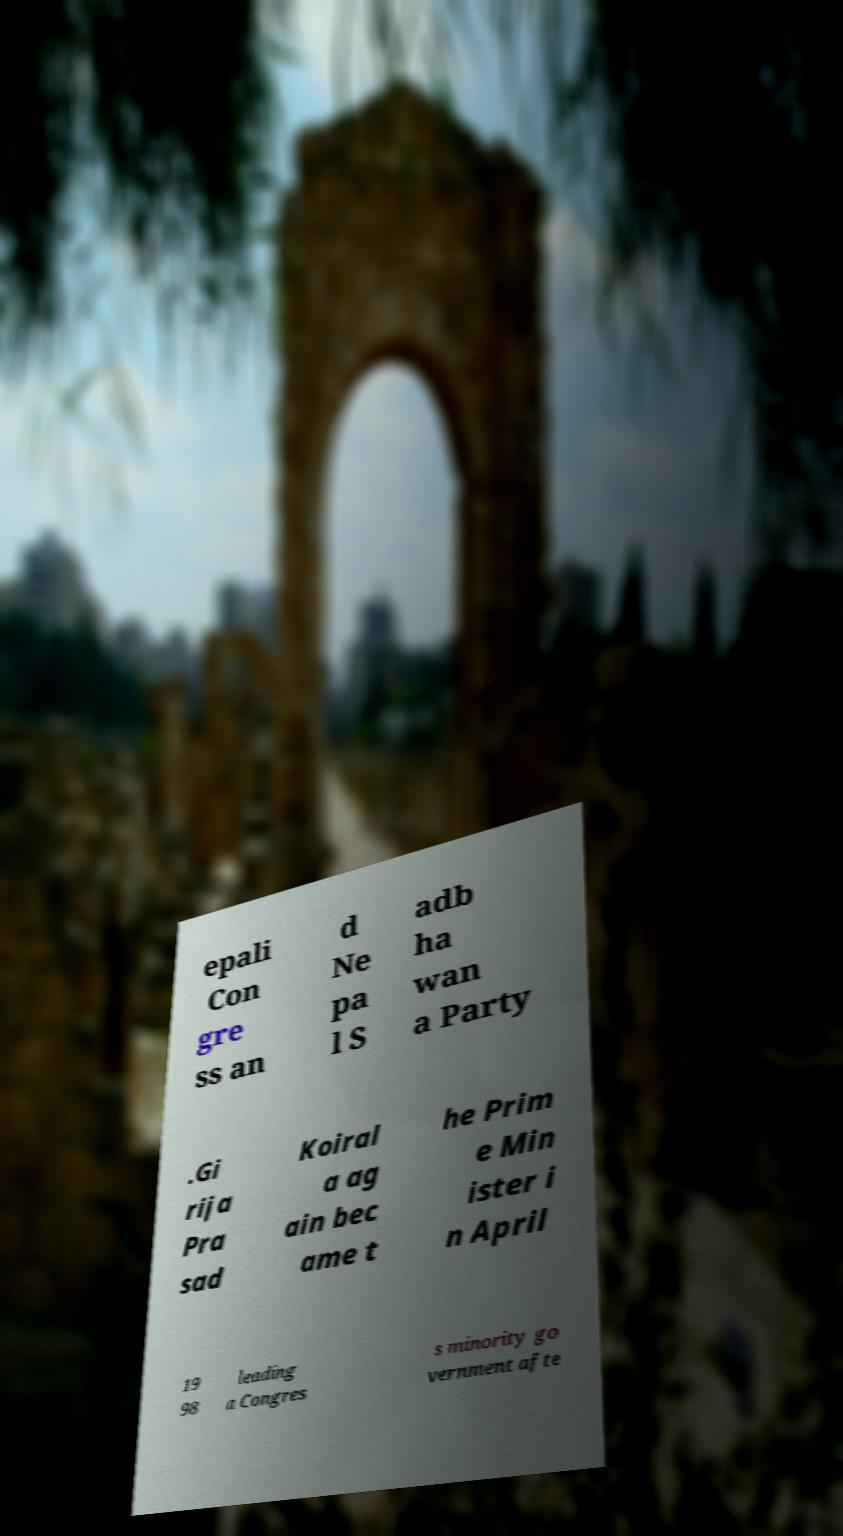Can you accurately transcribe the text from the provided image for me? epali Con gre ss an d Ne pa l S adb ha wan a Party .Gi rija Pra sad Koiral a ag ain bec ame t he Prim e Min ister i n April 19 98 leading a Congres s minority go vernment afte 